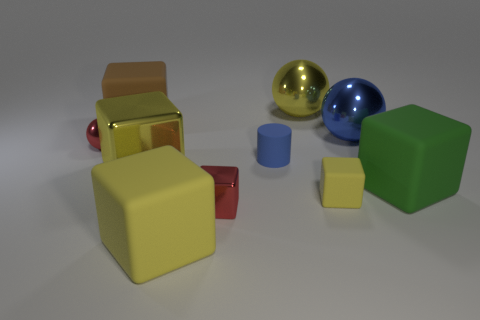Is the color of the cylinder the same as the tiny rubber block?
Offer a very short reply. No. How many large objects are both right of the small red cube and behind the tiny red sphere?
Provide a succinct answer. 2. There is a small yellow thing in front of the blue cylinder; what is its shape?
Give a very brief answer. Cube. Are there fewer blue metal spheres to the right of the green matte block than big brown matte blocks that are left of the blue matte object?
Offer a very short reply. Yes. Do the tiny thing that is on the left side of the small metallic cube and the large yellow thing that is behind the cylinder have the same material?
Ensure brevity in your answer.  Yes. What is the shape of the large green rubber object?
Ensure brevity in your answer.  Cube. Are there more small blocks on the left side of the yellow metallic ball than large yellow things to the right of the small blue rubber cylinder?
Provide a succinct answer. No. There is a big metallic object that is in front of the big blue metallic ball; does it have the same shape as the red metal object on the right side of the big brown matte cube?
Your response must be concise. Yes. What number of other things are the same size as the blue cylinder?
Offer a terse response. 3. How big is the rubber cylinder?
Your answer should be compact. Small. 